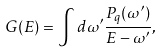<formula> <loc_0><loc_0><loc_500><loc_500>G ( E ) = \int d \omega ^ { \prime } \frac { P _ { q } ( \omega ^ { \prime } ) } { E - \omega ^ { \prime } } ,</formula> 